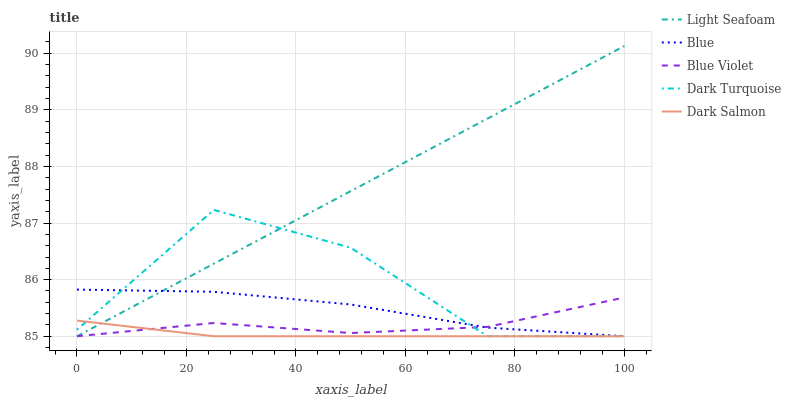Does Dark Salmon have the minimum area under the curve?
Answer yes or no. Yes. Does Light Seafoam have the maximum area under the curve?
Answer yes or no. Yes. Does Dark Turquoise have the minimum area under the curve?
Answer yes or no. No. Does Dark Turquoise have the maximum area under the curve?
Answer yes or no. No. Is Light Seafoam the smoothest?
Answer yes or no. Yes. Is Dark Turquoise the roughest?
Answer yes or no. Yes. Is Dark Turquoise the smoothest?
Answer yes or no. No. Is Light Seafoam the roughest?
Answer yes or no. No. Does Blue have the lowest value?
Answer yes or no. Yes. Does Light Seafoam have the highest value?
Answer yes or no. Yes. Does Dark Turquoise have the highest value?
Answer yes or no. No. Does Dark Salmon intersect Blue Violet?
Answer yes or no. Yes. Is Dark Salmon less than Blue Violet?
Answer yes or no. No. Is Dark Salmon greater than Blue Violet?
Answer yes or no. No. 